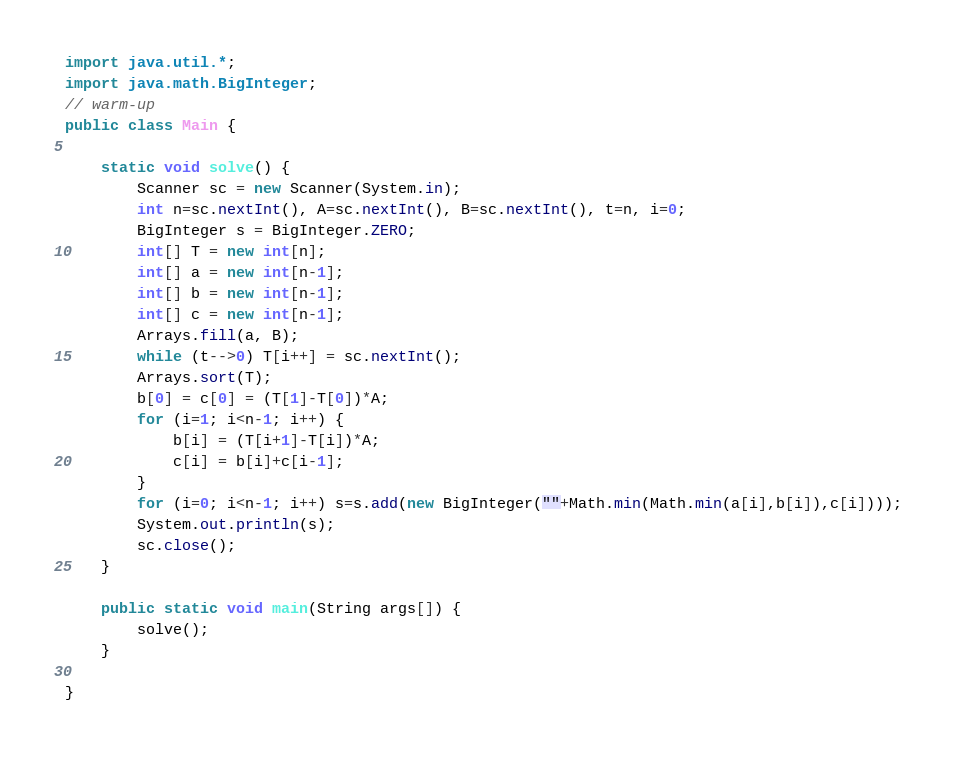Convert code to text. <code><loc_0><loc_0><loc_500><loc_500><_Java_>import java.util.*;
import java.math.BigInteger;
// warm-up
public class Main {

	static void solve() {
		Scanner sc = new Scanner(System.in);
		int n=sc.nextInt(), A=sc.nextInt(), B=sc.nextInt(), t=n, i=0;
		BigInteger s = BigInteger.ZERO;
		int[] T = new int[n];
		int[] a = new int[n-1];
		int[] b = new int[n-1];
		int[] c = new int[n-1];
		Arrays.fill(a, B);
		while (t-->0) T[i++] = sc.nextInt();
		Arrays.sort(T);
		b[0] = c[0] = (T[1]-T[0])*A;
		for (i=1; i<n-1; i++) {
			b[i] = (T[i+1]-T[i])*A;
			c[i] = b[i]+c[i-1];
		}
		for (i=0; i<n-1; i++) s=s.add(new BigInteger(""+Math.min(Math.min(a[i],b[i]),c[i])));
		System.out.println(s);
		sc.close();			
	}

	public static void main(String args[]) {
		solve();
	}

}</code> 